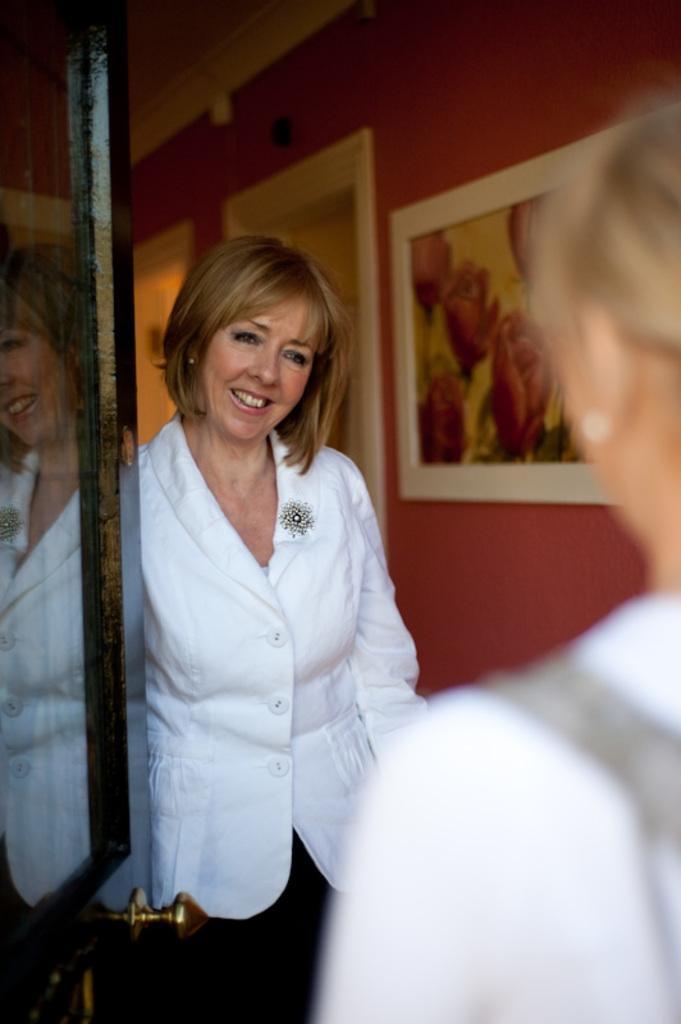Can you describe this image briefly? In this picture there is a lady in the center of the image and there is a door on the left side of the image, there is another lady on the right side of the image. 